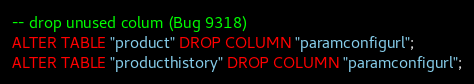<code> <loc_0><loc_0><loc_500><loc_500><_SQL_>-- drop unused colum (Bug 9318)
ALTER TABLE "product" DROP COLUMN "paramconfigurl";
ALTER TABLE "producthistory" DROP COLUMN "paramconfigurl";</code> 